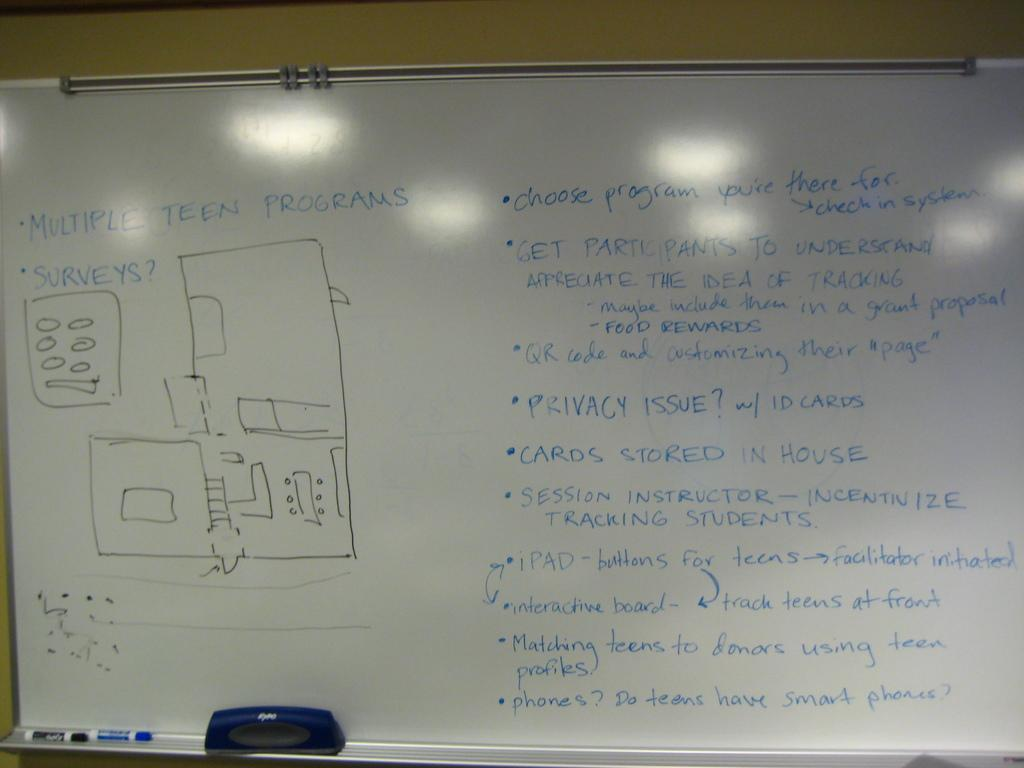<image>
Render a clear and concise summary of the photo. A white board shows many bullet points, including one that says "multiple teen surveys." 